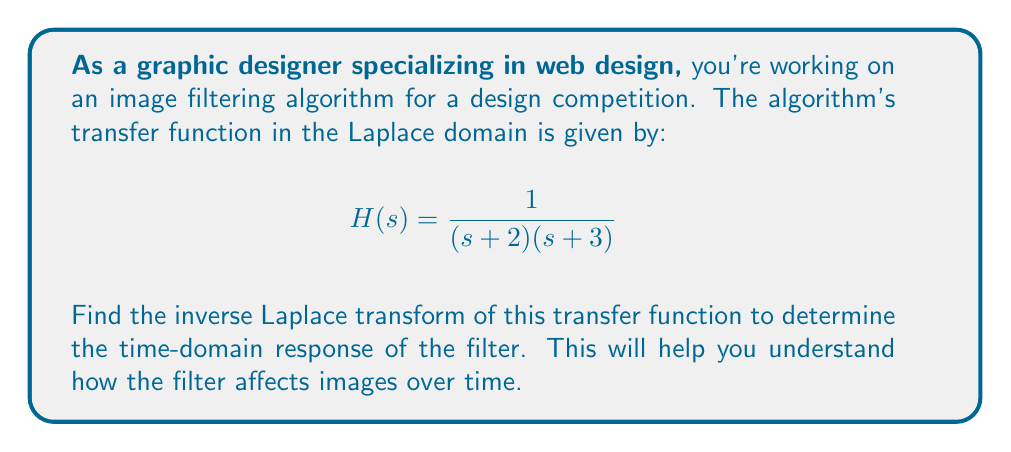Give your solution to this math problem. To find the inverse Laplace transform, we'll use the partial fraction decomposition method:

1) First, we set up the partial fraction decomposition:
   $$\frac{1}{(s + 2)(s + 3)} = \frac{A}{s + 2} + \frac{B}{s + 3}$$

2) Find a common denominator:
   $$\frac{1}{(s + 2)(s + 3)} = \frac{A(s + 3) + B(s + 2)}{(s + 2)(s + 3)}$$

3) Equate numerators:
   $$1 = A(s + 3) + B(s + 2)$$

4) Solve for A and B:
   When $s = -2$: $1 = A(1) \Rightarrow A = 1$
   When $s = -3$: $1 = B(-1) \Rightarrow B = -1$

5) Rewrite the transfer function:
   $$H(s) = \frac{1}{s + 2} - \frac{1}{s + 3}$$

6) Use the Laplace transform table to find the inverse:
   $\mathcal{L}^{-1}\{\frac{1}{s + a}\} = e^{-at}$

   Therefore:
   $$h(t) = e^{-2t} - e^{-3t}$$

7) Apply the unit step function $u(t)$ to ensure causality:
   $$h(t) = (e^{-2t} - e^{-3t})u(t)$$
Answer: $h(t) = (e^{-2t} - e^{-3t})u(t)$ 